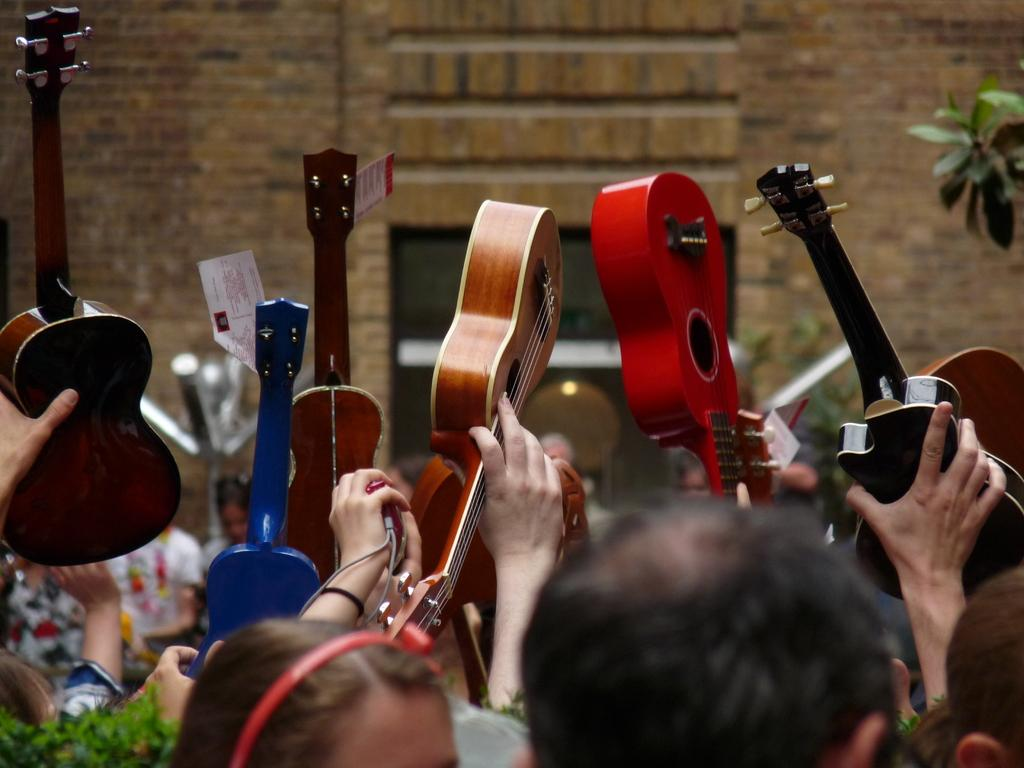How many persons are in the image? There are persons in the image. What are the persons doing in the image? The persons are raising their hands and holding colorful guitars. What can be seen on the sides of the image? Planets are visible on both the right and left sides of the image. Are there any additional details about the guitars? Yes, there are rate tags on the guitars. What type of pump is visible in the image? There is no pump present in the image. Can you tell me the statement made by the planets in the image? The planets in the image are not making any statements; they are simply visible in the background. 